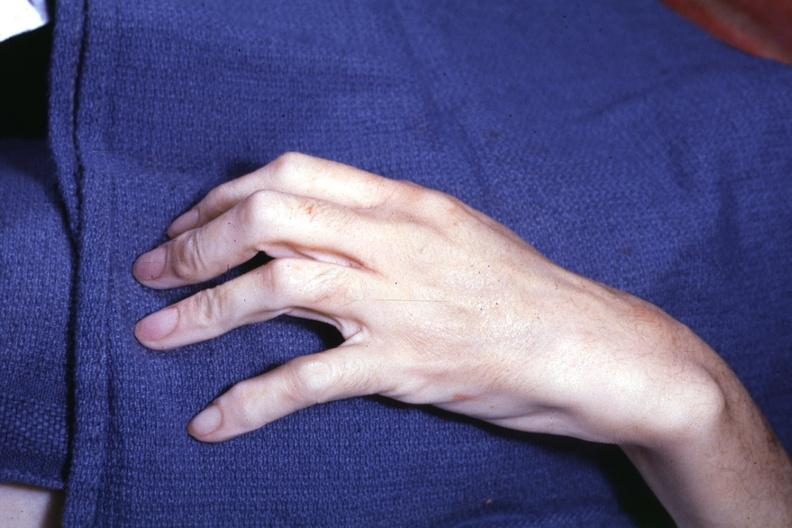what is present?
Answer the question using a single word or phrase. Arachnodactyly 